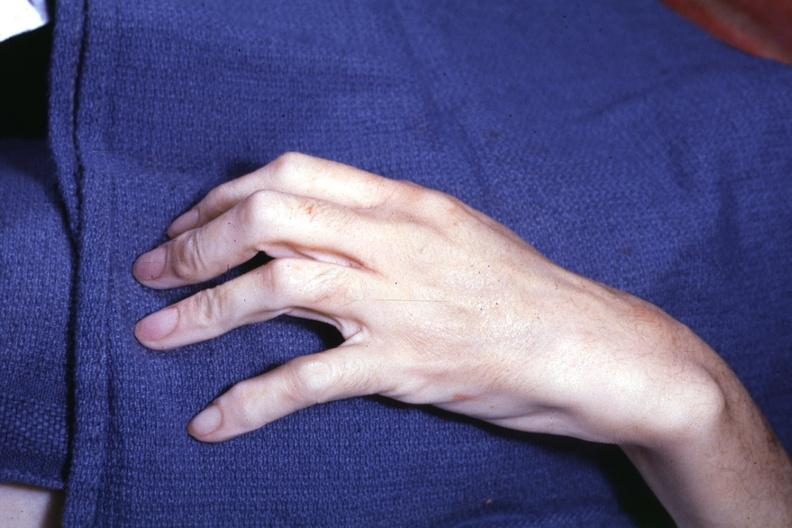what is present?
Answer the question using a single word or phrase. Arachnodactyly 